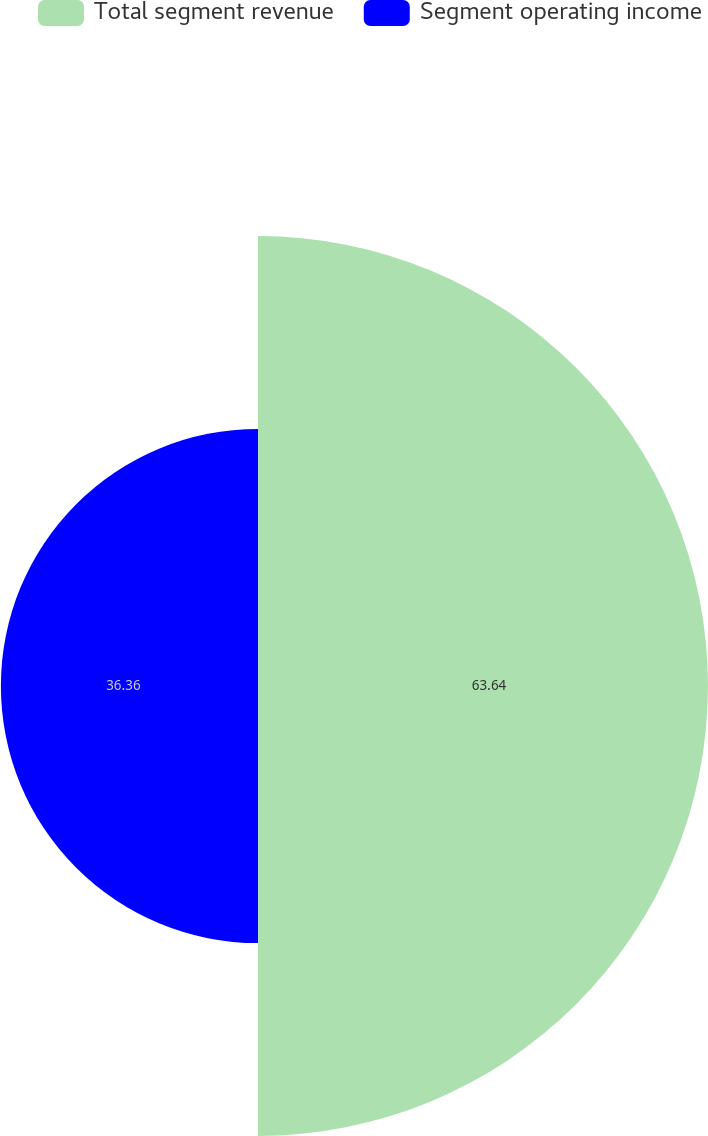Convert chart to OTSL. <chart><loc_0><loc_0><loc_500><loc_500><pie_chart><fcel>Total segment revenue<fcel>Segment operating income<nl><fcel>63.64%<fcel>36.36%<nl></chart> 